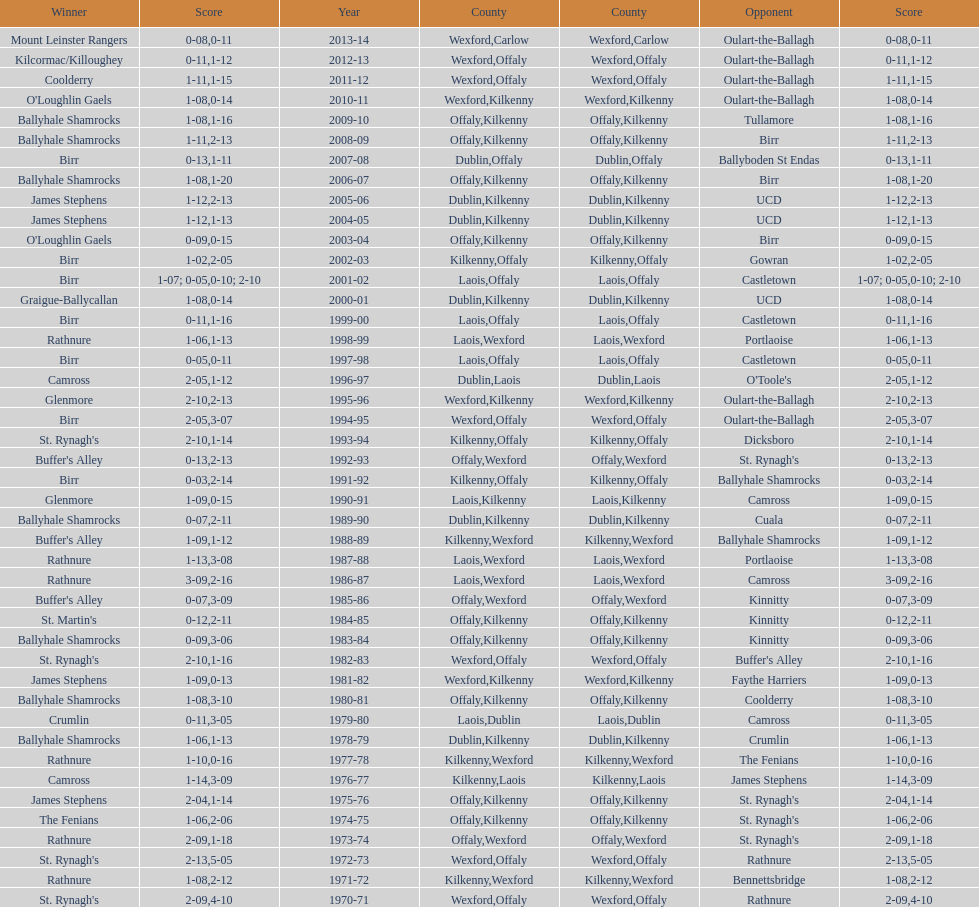Which team won the leinster senior club hurling championships previous to the last time birr won? Ballyhale Shamrocks. 